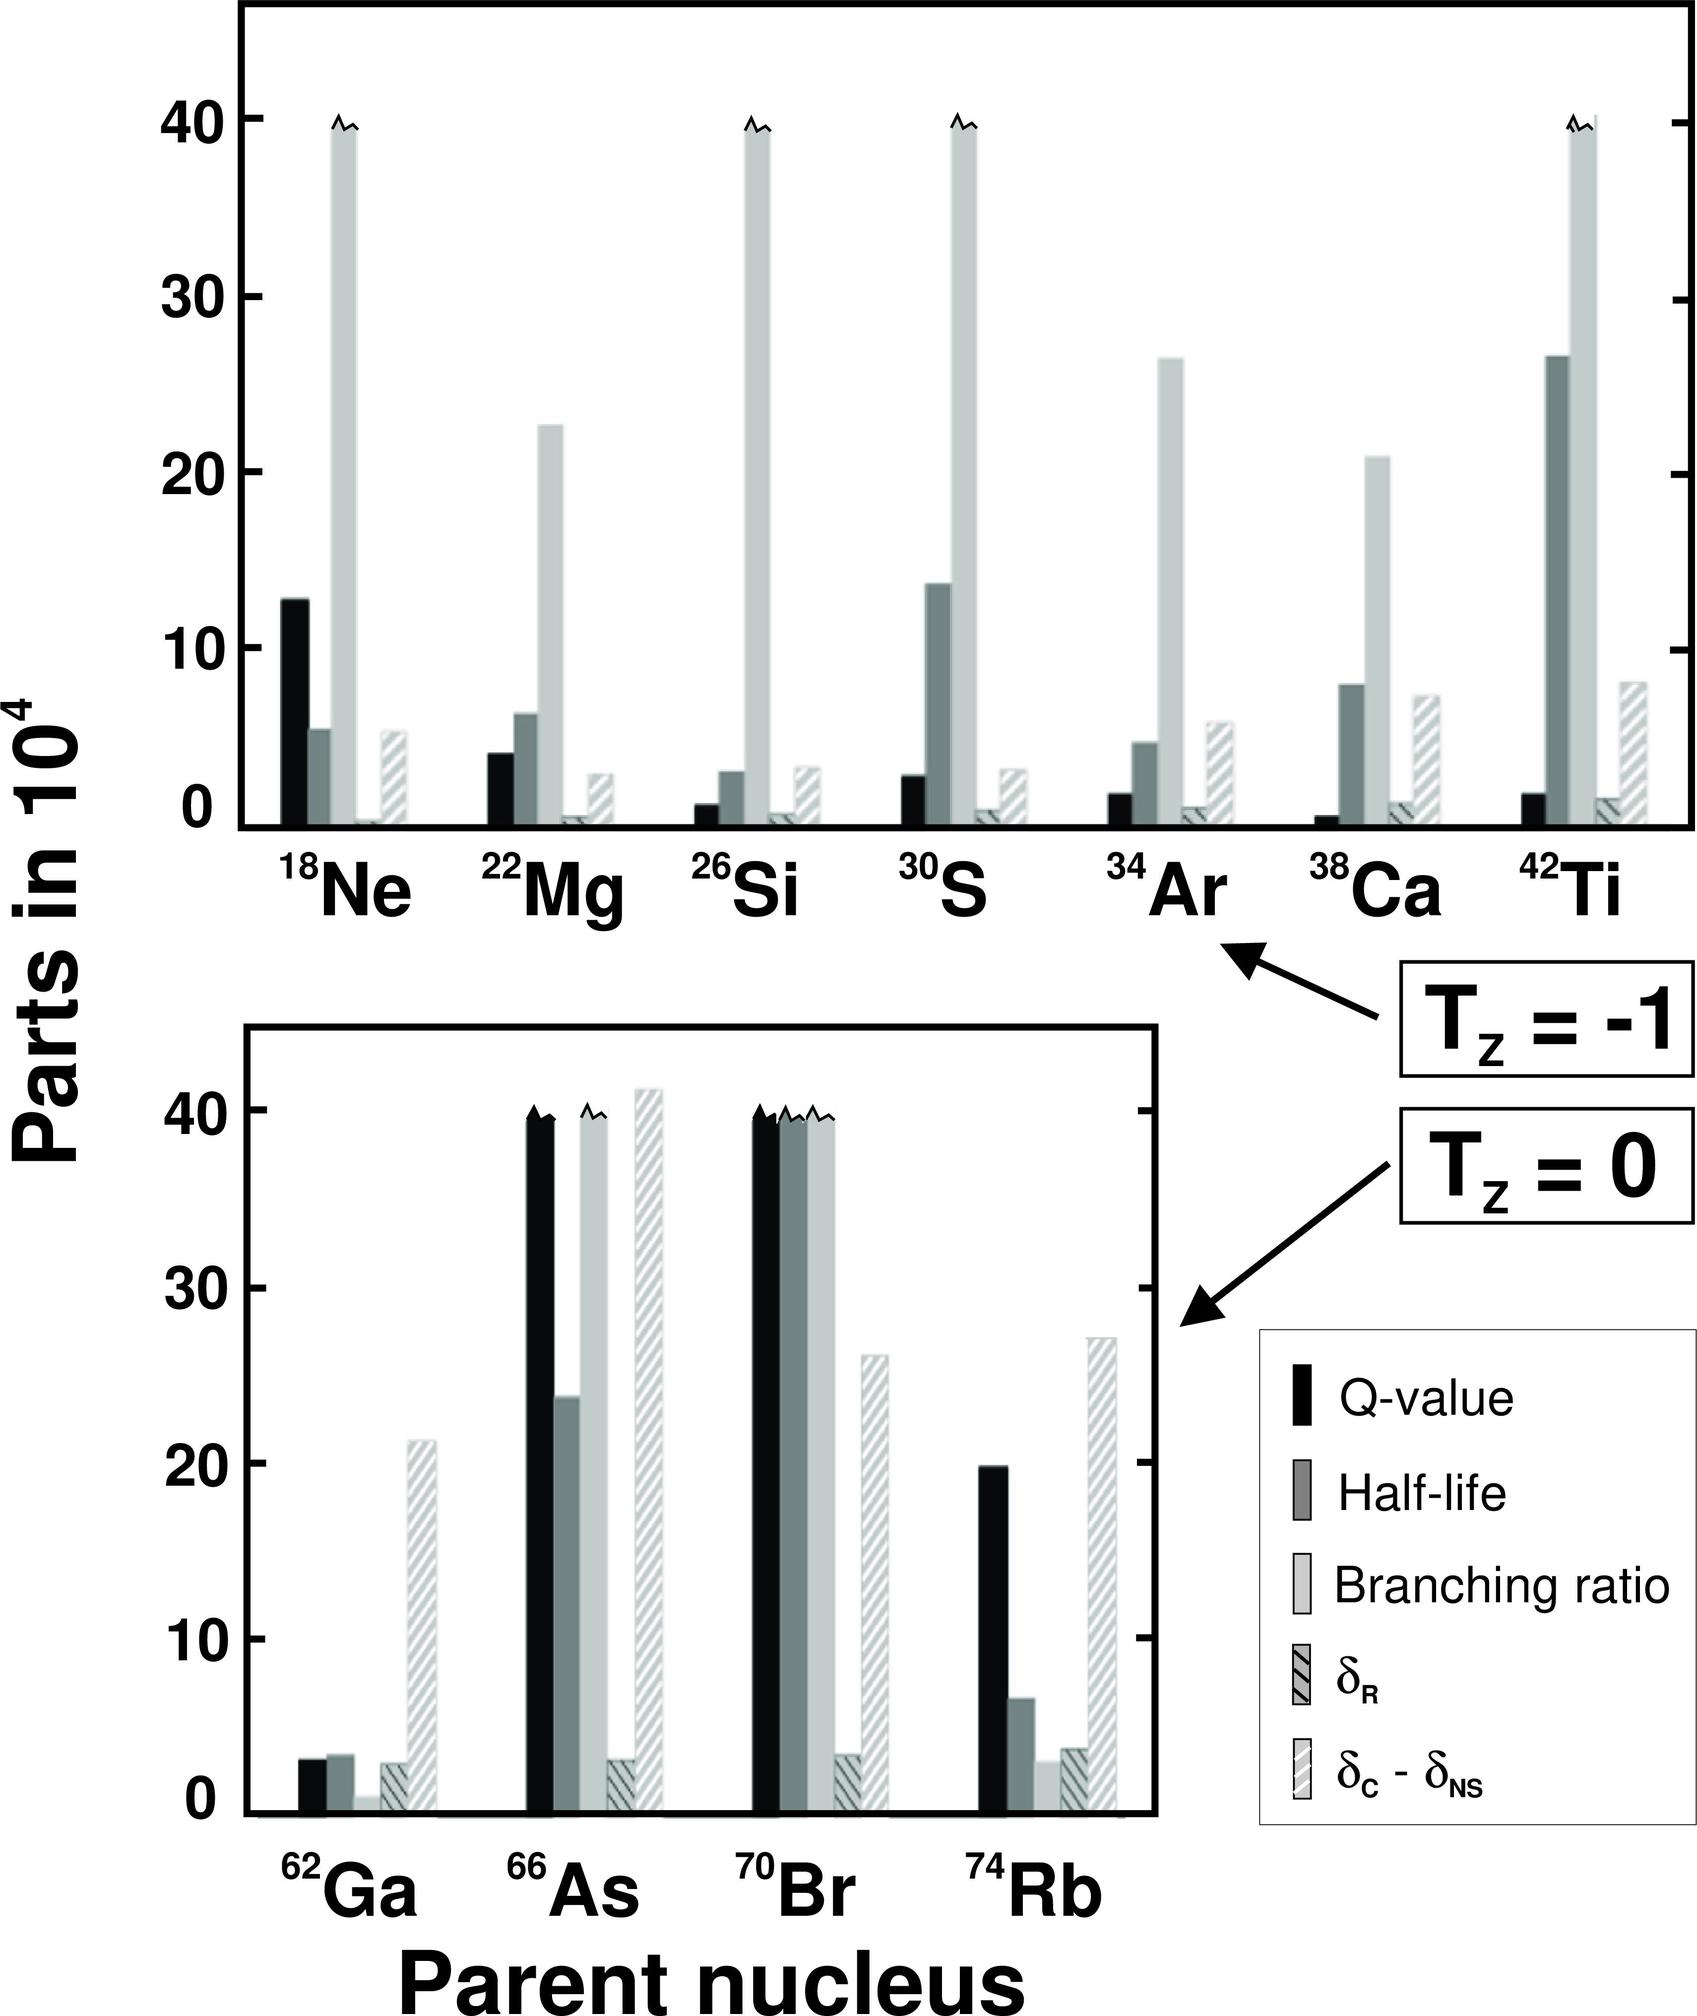Based on the given figure, which parent nucleus has the highest Q-value? A) \( ^{18}Ne \) B) \( ^{22}Mg \) C) \( ^{30}S \) D) \( ^{74}Rb \) The Q-value is represented by the black bars in the graph. \( ^{22}Mg \) has the tallest black bar in the first section of the graph, indicating that it has the highest Q-value among the listed options. Therefore, the correct answer is B) \( ^{22}Mg \). 